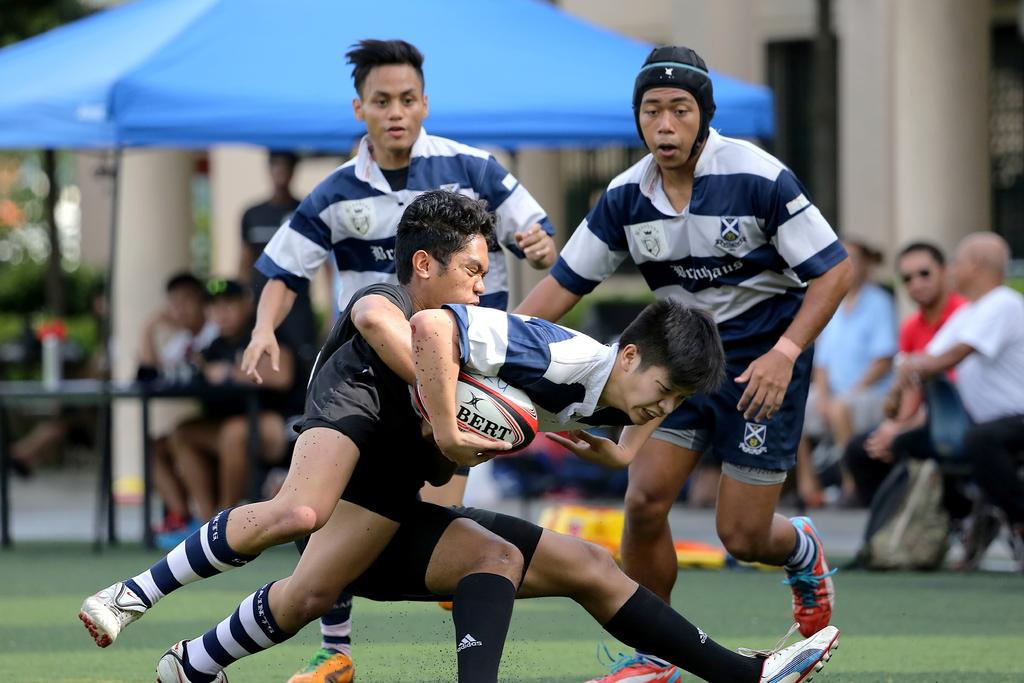What are the people in the image doing? There are people playing in the image. Are there any spectators in the image? Yes, there are people watching in the image. What question is being asked by the person in the image? There is no person asking a question in the image; the people are either playing or watching. 